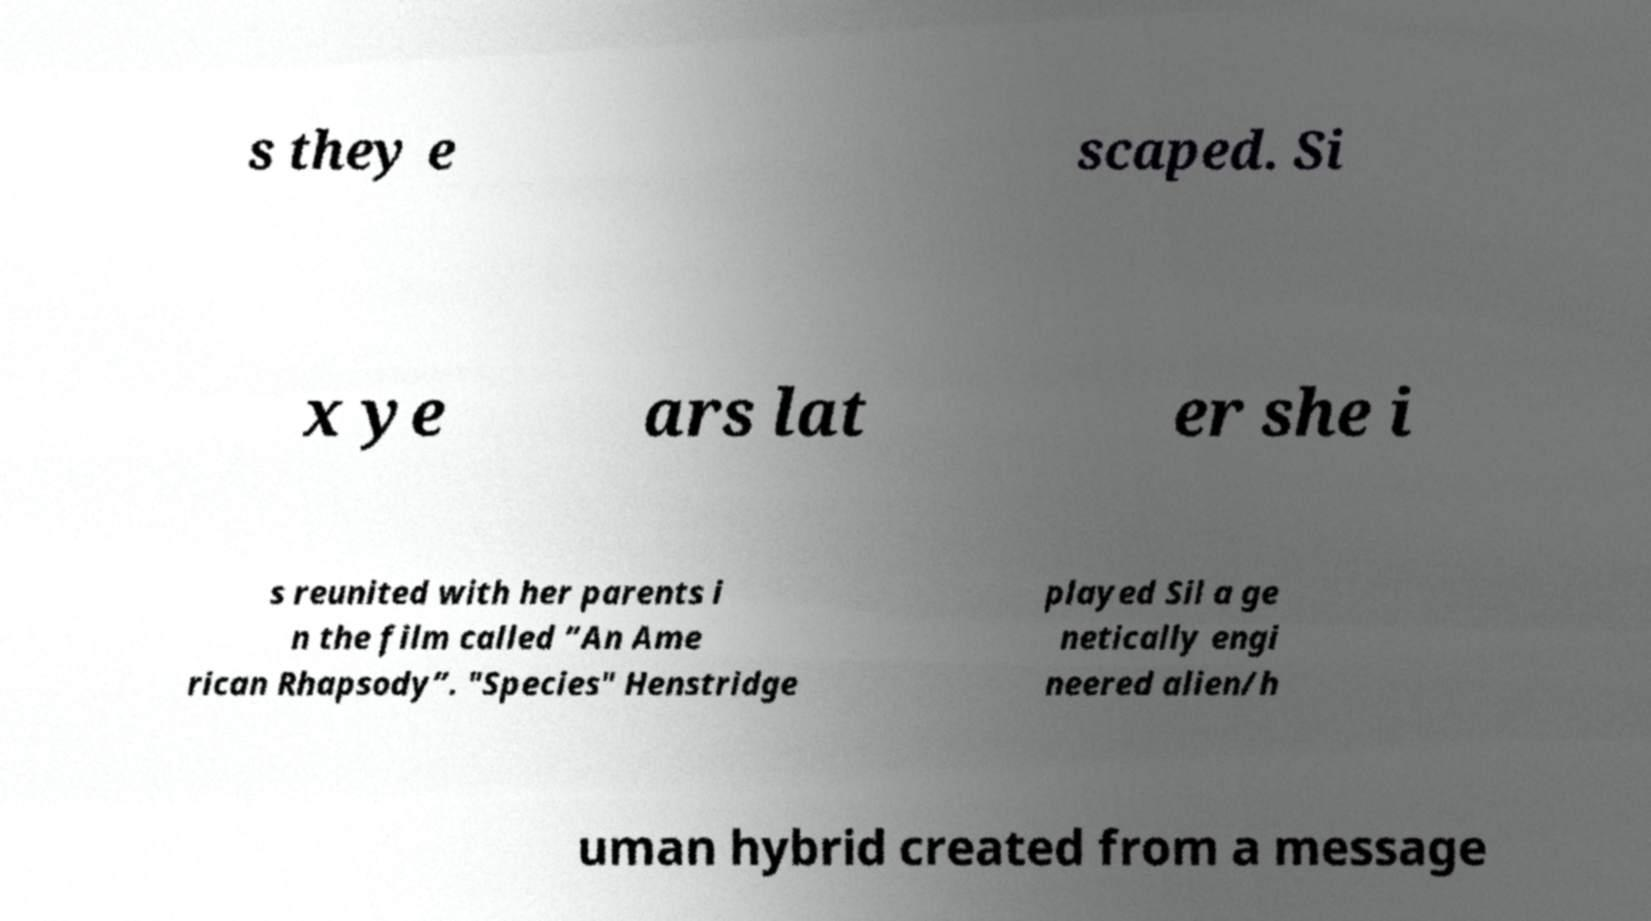Can you accurately transcribe the text from the provided image for me? s they e scaped. Si x ye ars lat er she i s reunited with her parents i n the film called “An Ame rican Rhapsody”. "Species" Henstridge played Sil a ge netically engi neered alien/h uman hybrid created from a message 